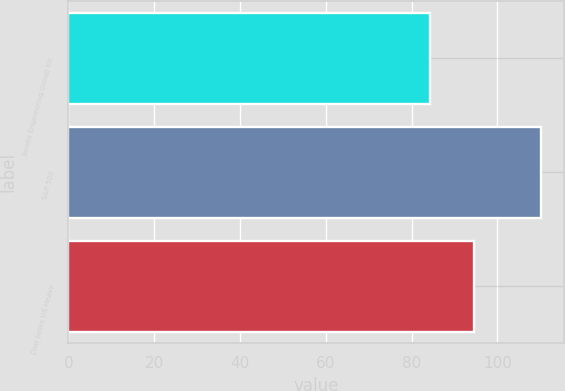<chart> <loc_0><loc_0><loc_500><loc_500><bar_chart><fcel>Jacobs Engineering Group Inc<fcel>S&P 500<fcel>Dow Jones US Heavy<nl><fcel>84.22<fcel>110.16<fcel>94.54<nl></chart> 